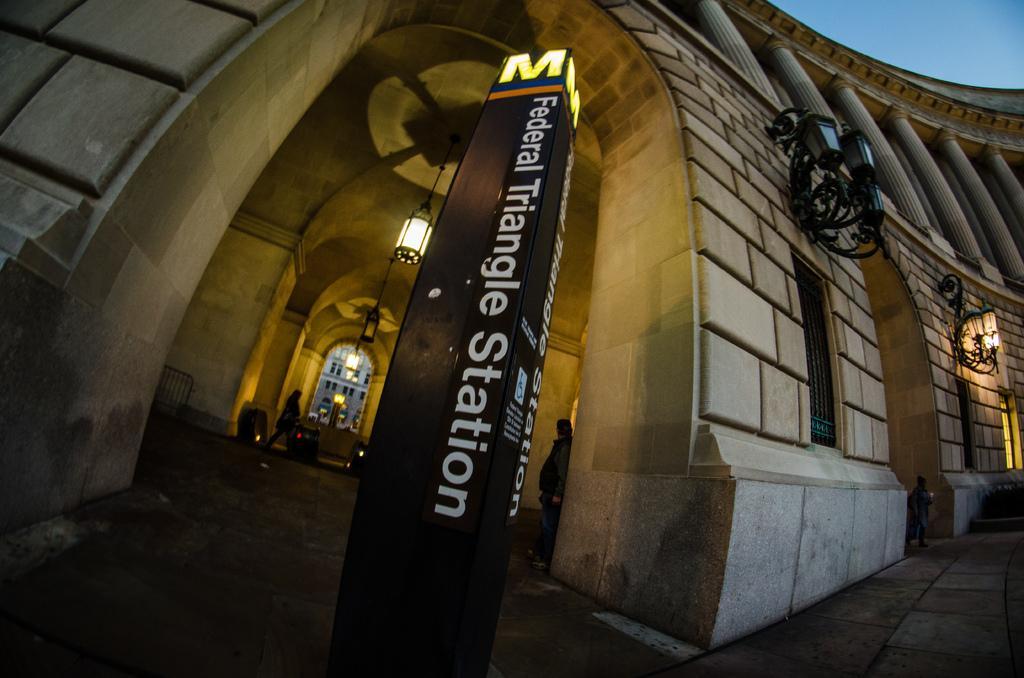Please provide a concise description of this image. It is a wide-angle picture of a building and there is a pillar in between the arch, there is some name written on that pillar, behind that there is a light and there are two people inside the arch. 